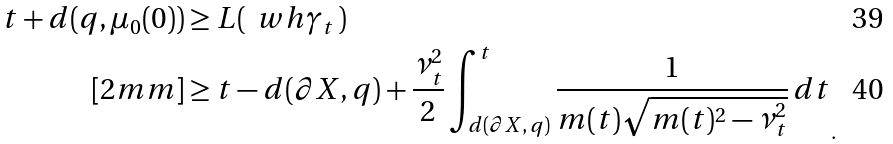<formula> <loc_0><loc_0><loc_500><loc_500>t + d ( q , \mu _ { 0 } ( 0 ) ) & \geq L ( \, \ w h { \gamma } _ { t } \, ) \\ [ 2 m m ] & \geq { t - d ( \partial X , q ) + \frac { \nu _ { t } ^ { 2 } } { 2 } \int _ { d ( \partial X , \, q ) } ^ { t } \frac { 1 } { m ( t ) \sqrt { m ( t ) ^ { 2 } - \nu _ { t } ^ { 2 } } } \, d t } _ { . }</formula> 